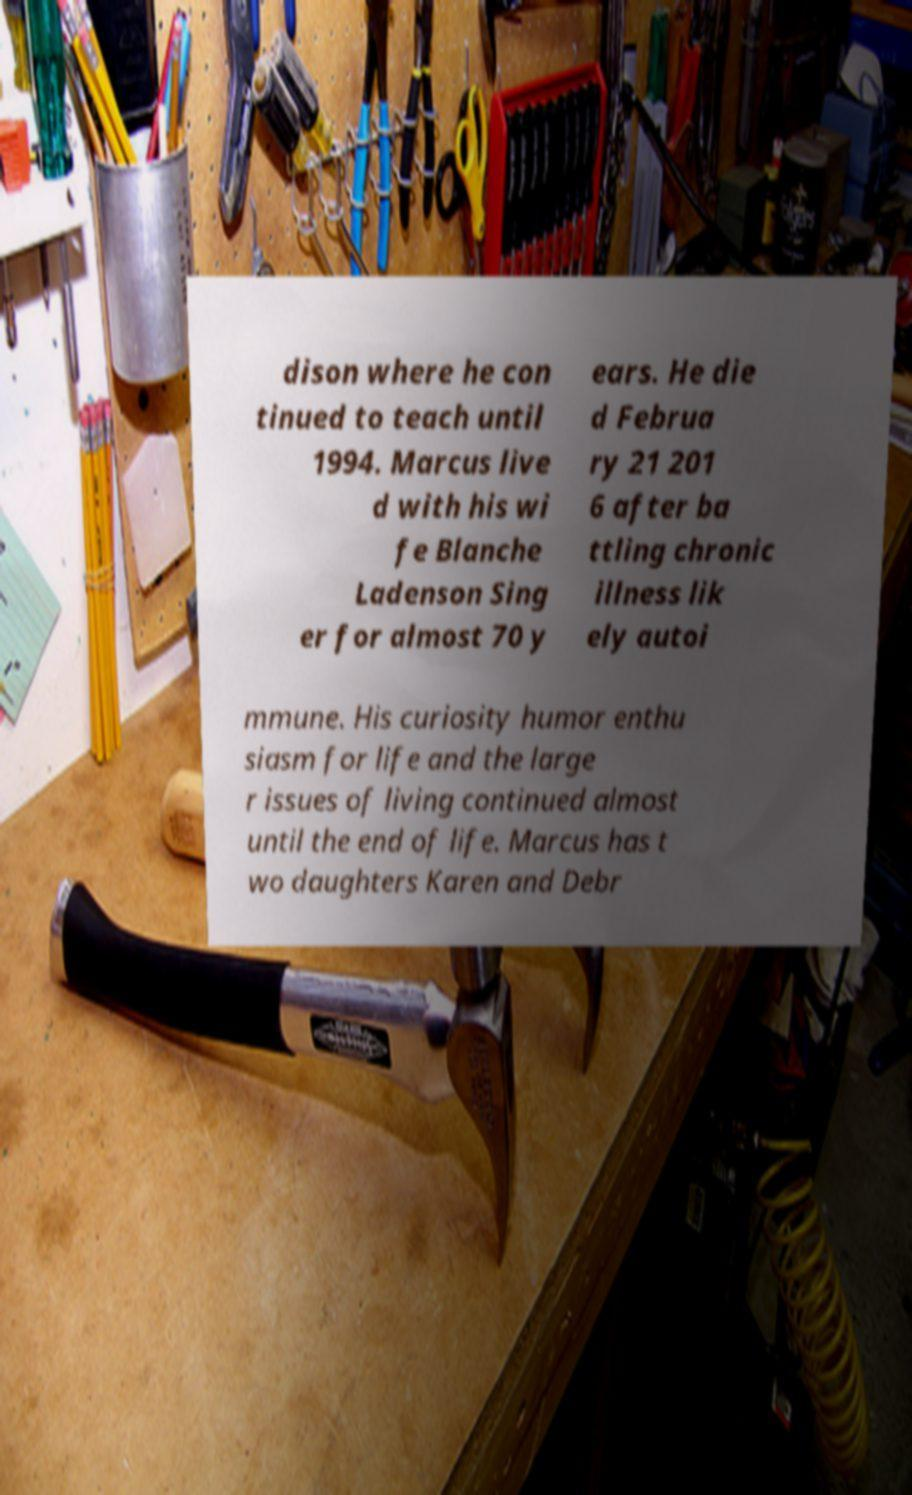Can you accurately transcribe the text from the provided image for me? dison where he con tinued to teach until 1994. Marcus live d with his wi fe Blanche Ladenson Sing er for almost 70 y ears. He die d Februa ry 21 201 6 after ba ttling chronic illness lik ely autoi mmune. His curiosity humor enthu siasm for life and the large r issues of living continued almost until the end of life. Marcus has t wo daughters Karen and Debr 